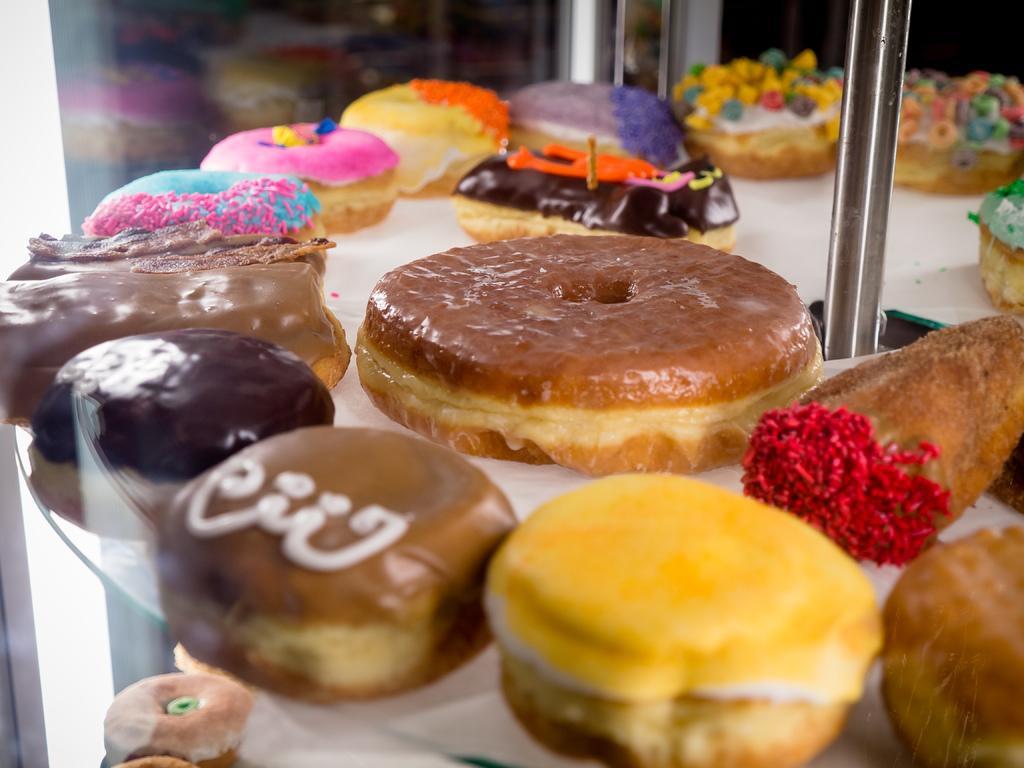Describe this image in one or two sentences. In the center of this picture we can see there are many number of donuts which are of different flavors. On the right we can see the metal rod. In the background we can see some other objects. 